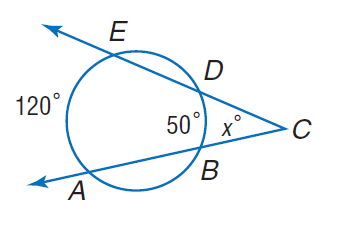Answer the mathemtical geometry problem and directly provide the correct option letter.
Question: Find x.
Choices: A: 35 B: 50 C: 100 D: 120 A 